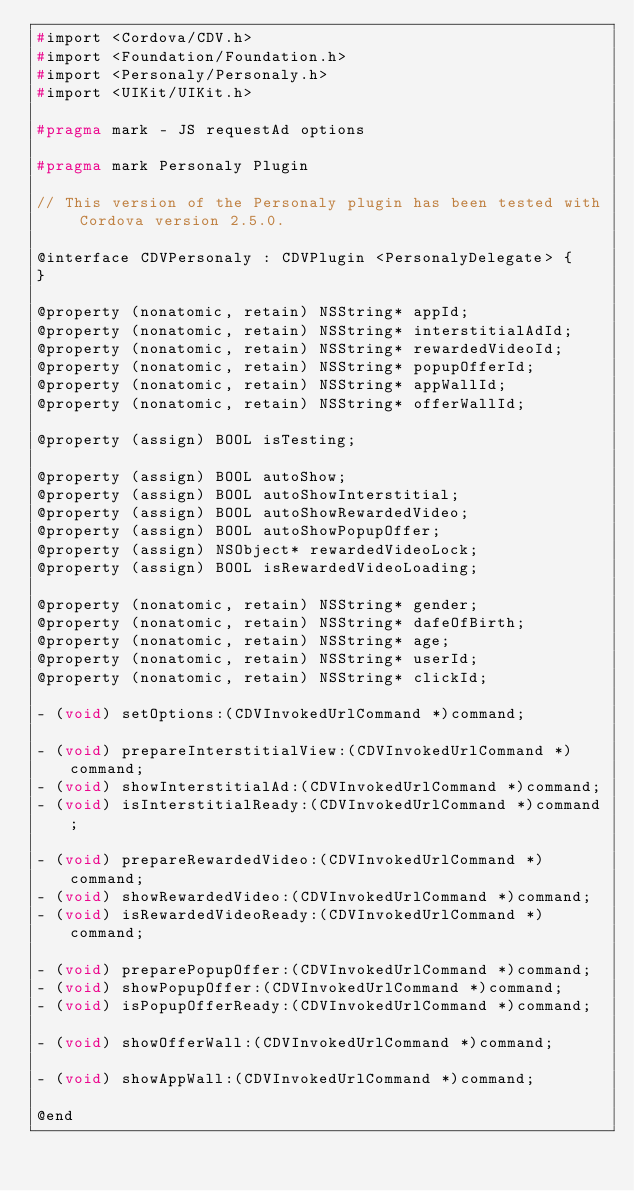Convert code to text. <code><loc_0><loc_0><loc_500><loc_500><_C_>#import <Cordova/CDV.h>
#import <Foundation/Foundation.h>
#import <Personaly/Personaly.h>
#import <UIKit/UIKit.h>

#pragma mark - JS requestAd options

#pragma mark Personaly Plugin

// This version of the Personaly plugin has been tested with Cordova version 2.5.0.

@interface CDVPersonaly : CDVPlugin <PersonalyDelegate> {
}

@property (nonatomic, retain) NSString* appId;
@property (nonatomic, retain) NSString* interstitialAdId;
@property (nonatomic, retain) NSString* rewardedVideoId;
@property (nonatomic, retain) NSString* popupOfferId;
@property (nonatomic, retain) NSString* appWallId;
@property (nonatomic, retain) NSString* offerWallId;

@property (assign) BOOL isTesting;

@property (assign) BOOL autoShow;
@property (assign) BOOL autoShowInterstitial;
@property (assign) BOOL autoShowRewardedVideo;
@property (assign) BOOL autoShowPopupOffer;
@property (assign) NSObject* rewardedVideoLock;
@property (assign) BOOL isRewardedVideoLoading;

@property (nonatomic, retain) NSString* gender;
@property (nonatomic, retain) NSString* dafeOfBirth;
@property (nonatomic, retain) NSString* age;
@property (nonatomic, retain) NSString* userId;
@property (nonatomic, retain) NSString* clickId;

- (void) setOptions:(CDVInvokedUrlCommand *)command;

- (void) prepareInterstitialView:(CDVInvokedUrlCommand *)command;
- (void) showInterstitialAd:(CDVInvokedUrlCommand *)command;
- (void) isInterstitialReady:(CDVInvokedUrlCommand *)command;

- (void) prepareRewardedVideo:(CDVInvokedUrlCommand *)command;
- (void) showRewardedVideo:(CDVInvokedUrlCommand *)command;
- (void) isRewardedVideoReady:(CDVInvokedUrlCommand *)command;

- (void) preparePopupOffer:(CDVInvokedUrlCommand *)command;
- (void) showPopupOffer:(CDVInvokedUrlCommand *)command;
- (void) isPopupOfferReady:(CDVInvokedUrlCommand *)command;

- (void) showOfferWall:(CDVInvokedUrlCommand *)command;

- (void) showAppWall:(CDVInvokedUrlCommand *)command;

@end
</code> 